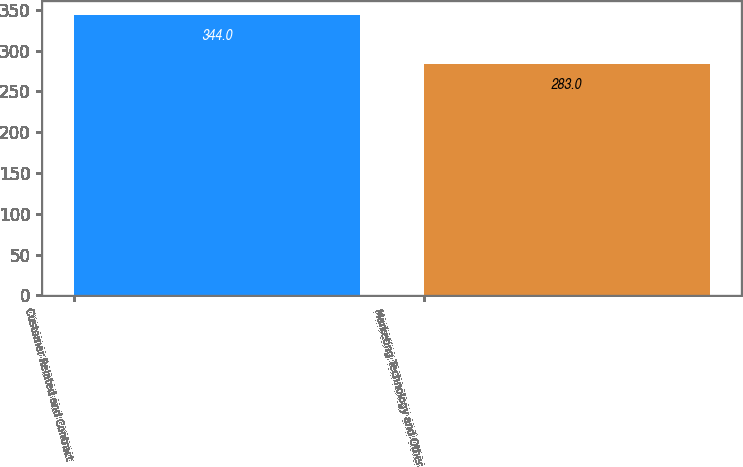Convert chart to OTSL. <chart><loc_0><loc_0><loc_500><loc_500><bar_chart><fcel>Customer Related and Contract<fcel>Marketing Technology and Other<nl><fcel>344<fcel>283<nl></chart> 